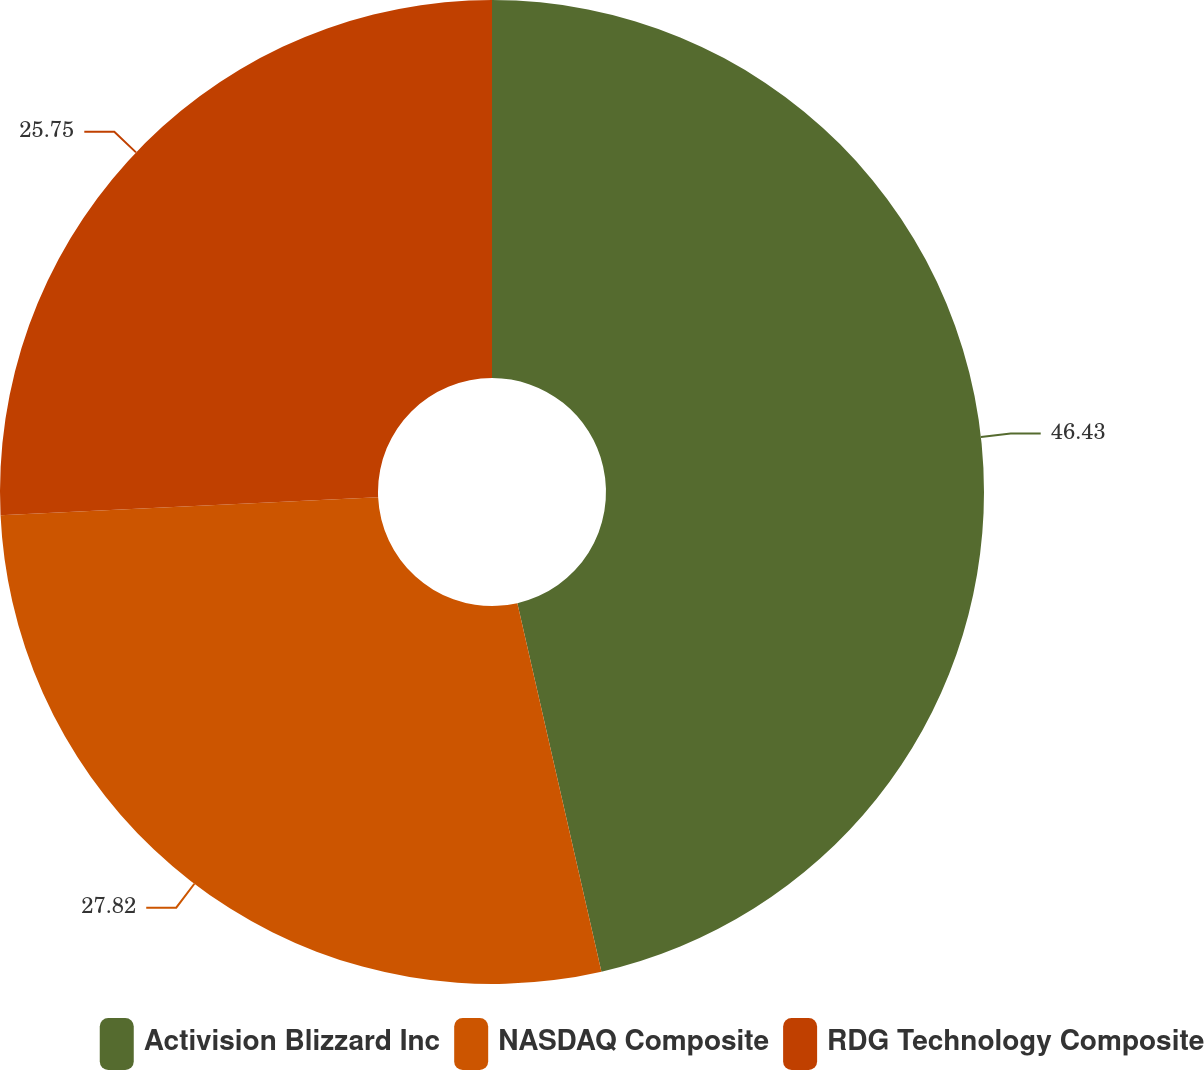Convert chart to OTSL. <chart><loc_0><loc_0><loc_500><loc_500><pie_chart><fcel>Activision Blizzard Inc<fcel>NASDAQ Composite<fcel>RDG Technology Composite<nl><fcel>46.43%<fcel>27.82%<fcel>25.75%<nl></chart> 